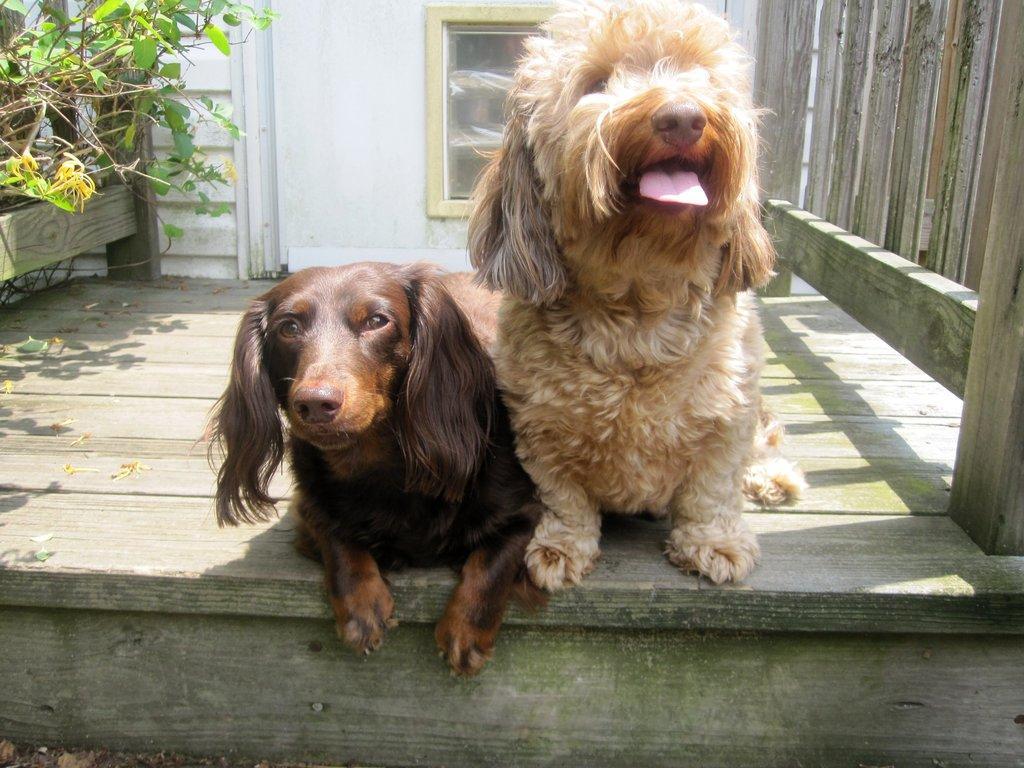Please provide a concise description of this image. In this picture, we can see animals on the wooden floor, we can see wooden fencing, plants, and the wall with door. 